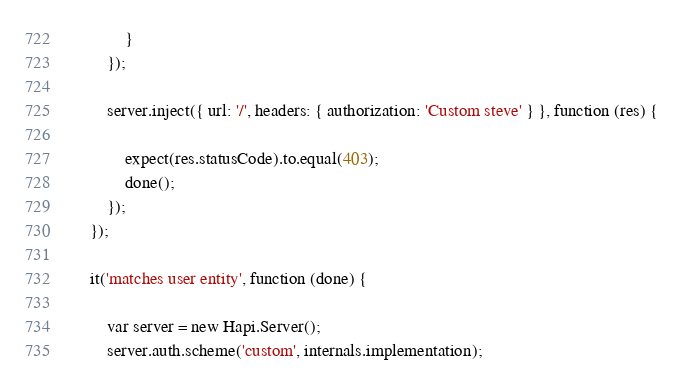<code> <loc_0><loc_0><loc_500><loc_500><_JavaScript_>            }
        });

        server.inject({ url: '/', headers: { authorization: 'Custom steve' } }, function (res) {

            expect(res.statusCode).to.equal(403);
            done();
        });
    });

    it('matches user entity', function (done) {

        var server = new Hapi.Server();
        server.auth.scheme('custom', internals.implementation);</code> 